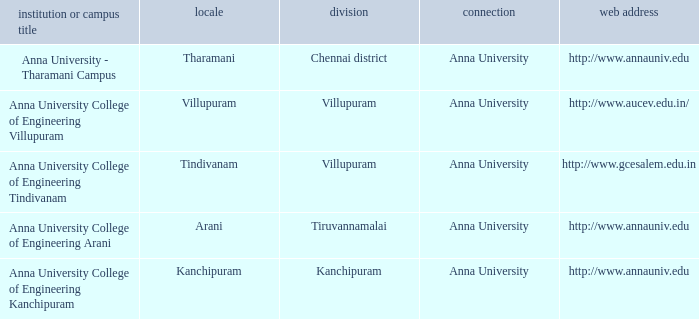What Weblink has a College or Campus Name of anna university college of engineering tindivanam? Http://www.gcesalem.edu.in. 